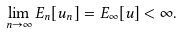Convert formula to latex. <formula><loc_0><loc_0><loc_500><loc_500>\lim _ { n \to \infty } E _ { n } [ u _ { n } ] = E _ { \infty } [ u ] < \infty .</formula> 